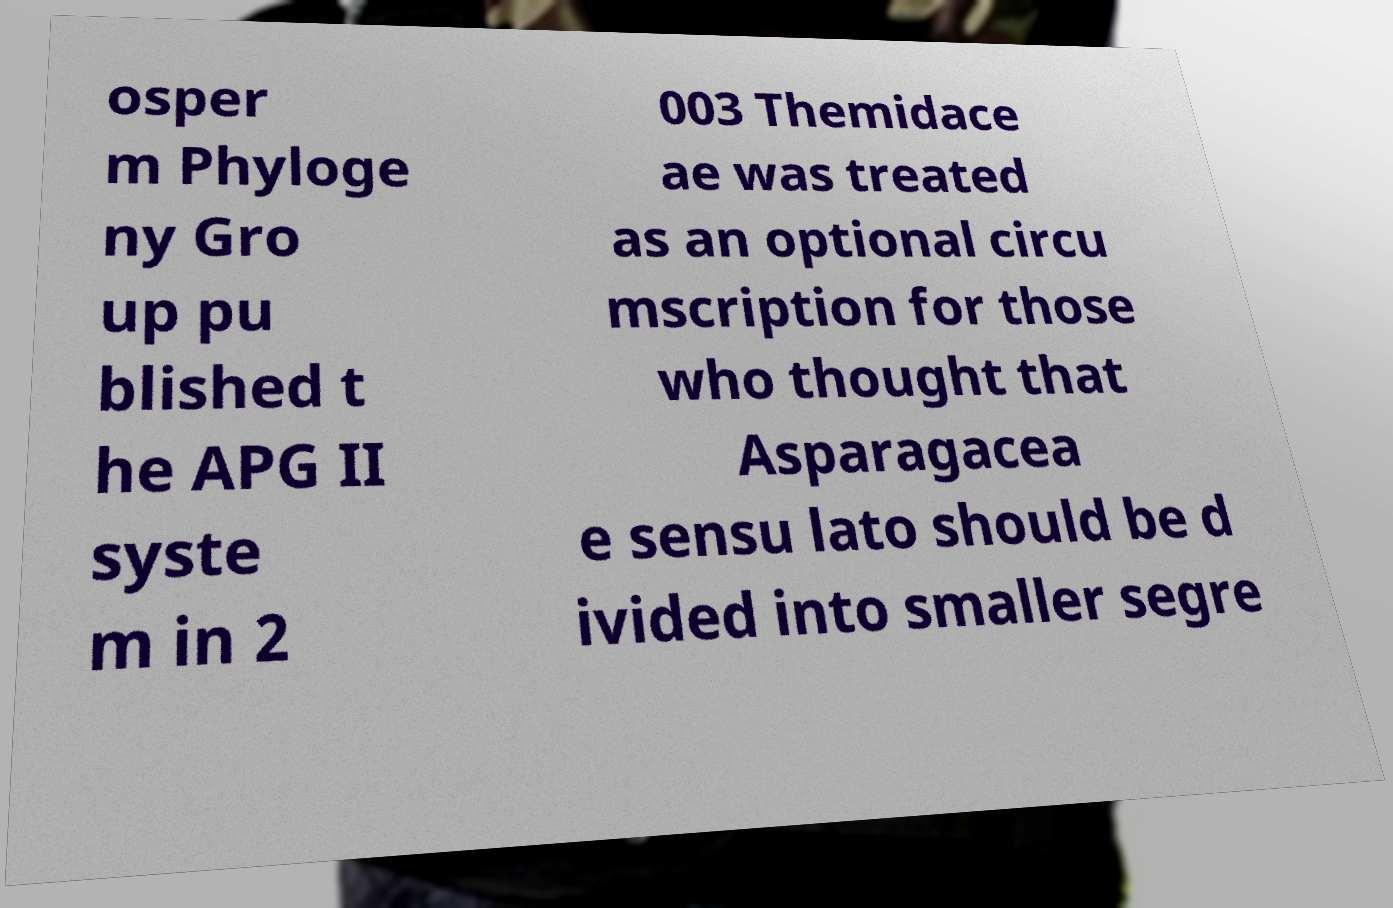Could you extract and type out the text from this image? osper m Phyloge ny Gro up pu blished t he APG II syste m in 2 003 Themidace ae was treated as an optional circu mscription for those who thought that Asparagacea e sensu lato should be d ivided into smaller segre 